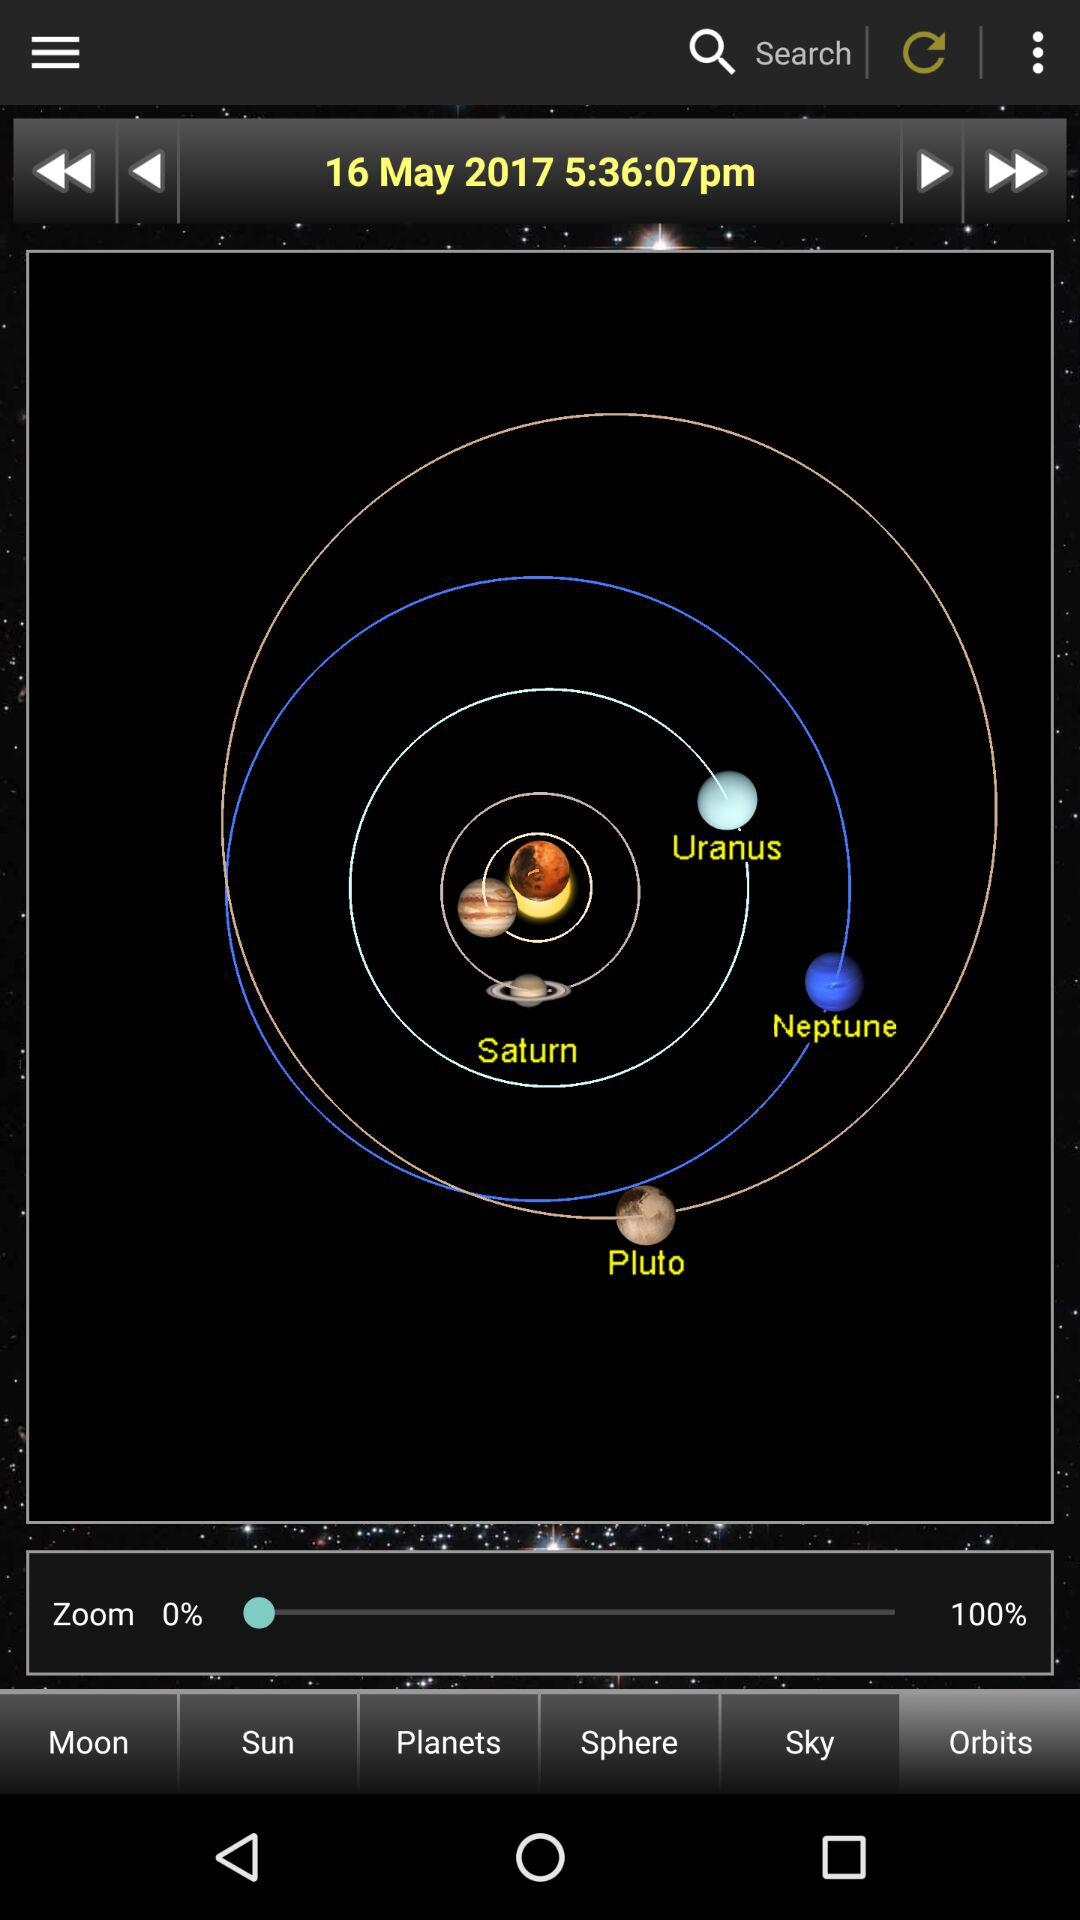Which tab am I on? You are on the tab "Orbits". 